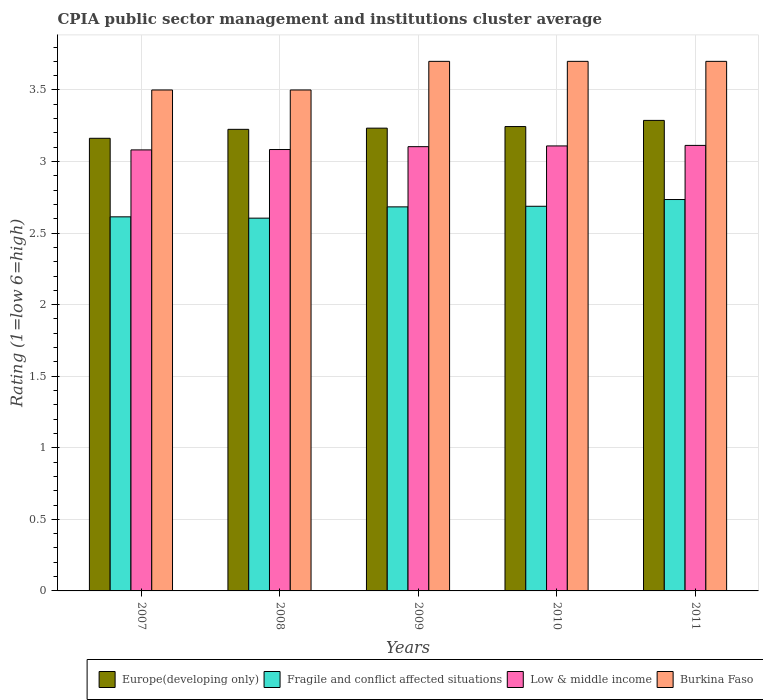How many different coloured bars are there?
Give a very brief answer. 4. Are the number of bars per tick equal to the number of legend labels?
Keep it short and to the point. Yes. How many bars are there on the 5th tick from the left?
Make the answer very short. 4. What is the CPIA rating in Fragile and conflict affected situations in 2009?
Offer a terse response. 2.68. Across all years, what is the maximum CPIA rating in Europe(developing only)?
Offer a very short reply. 3.29. Across all years, what is the minimum CPIA rating in Fragile and conflict affected situations?
Your answer should be compact. 2.6. In which year was the CPIA rating in Low & middle income maximum?
Ensure brevity in your answer.  2011. What is the total CPIA rating in Fragile and conflict affected situations in the graph?
Provide a short and direct response. 13.32. What is the difference between the CPIA rating in Low & middle income in 2007 and that in 2009?
Your answer should be compact. -0.02. What is the difference between the CPIA rating in Fragile and conflict affected situations in 2007 and the CPIA rating in Burkina Faso in 2010?
Your answer should be compact. -1.09. What is the average CPIA rating in Europe(developing only) per year?
Ensure brevity in your answer.  3.23. In the year 2009, what is the difference between the CPIA rating in Fragile and conflict affected situations and CPIA rating in Low & middle income?
Offer a terse response. -0.42. What is the ratio of the CPIA rating in Fragile and conflict affected situations in 2007 to that in 2009?
Give a very brief answer. 0.97. Is the CPIA rating in Burkina Faso in 2010 less than that in 2011?
Your response must be concise. No. What is the difference between the highest and the second highest CPIA rating in Low & middle income?
Offer a terse response. 0. What is the difference between the highest and the lowest CPIA rating in Low & middle income?
Provide a succinct answer. 0.03. Is the sum of the CPIA rating in Burkina Faso in 2010 and 2011 greater than the maximum CPIA rating in Fragile and conflict affected situations across all years?
Provide a short and direct response. Yes. What does the 2nd bar from the left in 2010 represents?
Make the answer very short. Fragile and conflict affected situations. What does the 2nd bar from the right in 2007 represents?
Give a very brief answer. Low & middle income. Is it the case that in every year, the sum of the CPIA rating in Fragile and conflict affected situations and CPIA rating in Europe(developing only) is greater than the CPIA rating in Burkina Faso?
Provide a short and direct response. Yes. How many bars are there?
Give a very brief answer. 20. How many years are there in the graph?
Give a very brief answer. 5. What is the difference between two consecutive major ticks on the Y-axis?
Your answer should be compact. 0.5. Does the graph contain grids?
Keep it short and to the point. Yes. How are the legend labels stacked?
Your response must be concise. Horizontal. What is the title of the graph?
Ensure brevity in your answer.  CPIA public sector management and institutions cluster average. What is the Rating (1=low 6=high) of Europe(developing only) in 2007?
Give a very brief answer. 3.16. What is the Rating (1=low 6=high) of Fragile and conflict affected situations in 2007?
Your answer should be compact. 2.61. What is the Rating (1=low 6=high) in Low & middle income in 2007?
Keep it short and to the point. 3.08. What is the Rating (1=low 6=high) of Burkina Faso in 2007?
Make the answer very short. 3.5. What is the Rating (1=low 6=high) of Europe(developing only) in 2008?
Your response must be concise. 3.23. What is the Rating (1=low 6=high) in Fragile and conflict affected situations in 2008?
Give a very brief answer. 2.6. What is the Rating (1=low 6=high) of Low & middle income in 2008?
Keep it short and to the point. 3.08. What is the Rating (1=low 6=high) in Burkina Faso in 2008?
Provide a short and direct response. 3.5. What is the Rating (1=low 6=high) in Europe(developing only) in 2009?
Make the answer very short. 3.23. What is the Rating (1=low 6=high) of Fragile and conflict affected situations in 2009?
Your answer should be compact. 2.68. What is the Rating (1=low 6=high) in Low & middle income in 2009?
Your answer should be compact. 3.1. What is the Rating (1=low 6=high) of Europe(developing only) in 2010?
Offer a terse response. 3.24. What is the Rating (1=low 6=high) in Fragile and conflict affected situations in 2010?
Your answer should be very brief. 2.69. What is the Rating (1=low 6=high) of Low & middle income in 2010?
Offer a very short reply. 3.11. What is the Rating (1=low 6=high) of Europe(developing only) in 2011?
Your answer should be compact. 3.29. What is the Rating (1=low 6=high) of Fragile and conflict affected situations in 2011?
Give a very brief answer. 2.73. What is the Rating (1=low 6=high) of Low & middle income in 2011?
Your response must be concise. 3.11. Across all years, what is the maximum Rating (1=low 6=high) in Europe(developing only)?
Keep it short and to the point. 3.29. Across all years, what is the maximum Rating (1=low 6=high) of Fragile and conflict affected situations?
Make the answer very short. 2.73. Across all years, what is the maximum Rating (1=low 6=high) in Low & middle income?
Your response must be concise. 3.11. Across all years, what is the minimum Rating (1=low 6=high) of Europe(developing only)?
Keep it short and to the point. 3.16. Across all years, what is the minimum Rating (1=low 6=high) of Fragile and conflict affected situations?
Provide a succinct answer. 2.6. Across all years, what is the minimum Rating (1=low 6=high) of Low & middle income?
Make the answer very short. 3.08. What is the total Rating (1=low 6=high) in Europe(developing only) in the graph?
Your answer should be very brief. 16.15. What is the total Rating (1=low 6=high) of Fragile and conflict affected situations in the graph?
Provide a succinct answer. 13.32. What is the total Rating (1=low 6=high) in Low & middle income in the graph?
Keep it short and to the point. 15.49. What is the difference between the Rating (1=low 6=high) in Europe(developing only) in 2007 and that in 2008?
Provide a succinct answer. -0.06. What is the difference between the Rating (1=low 6=high) in Fragile and conflict affected situations in 2007 and that in 2008?
Give a very brief answer. 0.01. What is the difference between the Rating (1=low 6=high) of Low & middle income in 2007 and that in 2008?
Ensure brevity in your answer.  -0. What is the difference between the Rating (1=low 6=high) of Europe(developing only) in 2007 and that in 2009?
Your response must be concise. -0.07. What is the difference between the Rating (1=low 6=high) of Fragile and conflict affected situations in 2007 and that in 2009?
Keep it short and to the point. -0.07. What is the difference between the Rating (1=low 6=high) of Low & middle income in 2007 and that in 2009?
Your response must be concise. -0.02. What is the difference between the Rating (1=low 6=high) in Burkina Faso in 2007 and that in 2009?
Give a very brief answer. -0.2. What is the difference between the Rating (1=low 6=high) in Europe(developing only) in 2007 and that in 2010?
Provide a succinct answer. -0.08. What is the difference between the Rating (1=low 6=high) of Fragile and conflict affected situations in 2007 and that in 2010?
Your answer should be very brief. -0.07. What is the difference between the Rating (1=low 6=high) of Low & middle income in 2007 and that in 2010?
Your answer should be very brief. -0.03. What is the difference between the Rating (1=low 6=high) of Burkina Faso in 2007 and that in 2010?
Ensure brevity in your answer.  -0.2. What is the difference between the Rating (1=low 6=high) in Europe(developing only) in 2007 and that in 2011?
Keep it short and to the point. -0.12. What is the difference between the Rating (1=low 6=high) in Fragile and conflict affected situations in 2007 and that in 2011?
Make the answer very short. -0.12. What is the difference between the Rating (1=low 6=high) of Low & middle income in 2007 and that in 2011?
Your response must be concise. -0.03. What is the difference between the Rating (1=low 6=high) of Europe(developing only) in 2008 and that in 2009?
Your response must be concise. -0.01. What is the difference between the Rating (1=low 6=high) of Fragile and conflict affected situations in 2008 and that in 2009?
Ensure brevity in your answer.  -0.08. What is the difference between the Rating (1=low 6=high) of Low & middle income in 2008 and that in 2009?
Offer a terse response. -0.02. What is the difference between the Rating (1=low 6=high) of Burkina Faso in 2008 and that in 2009?
Your answer should be very brief. -0.2. What is the difference between the Rating (1=low 6=high) in Europe(developing only) in 2008 and that in 2010?
Give a very brief answer. -0.02. What is the difference between the Rating (1=low 6=high) of Fragile and conflict affected situations in 2008 and that in 2010?
Your answer should be very brief. -0.08. What is the difference between the Rating (1=low 6=high) of Low & middle income in 2008 and that in 2010?
Your answer should be compact. -0.03. What is the difference between the Rating (1=low 6=high) of Burkina Faso in 2008 and that in 2010?
Make the answer very short. -0.2. What is the difference between the Rating (1=low 6=high) in Europe(developing only) in 2008 and that in 2011?
Make the answer very short. -0.06. What is the difference between the Rating (1=low 6=high) in Fragile and conflict affected situations in 2008 and that in 2011?
Provide a succinct answer. -0.13. What is the difference between the Rating (1=low 6=high) in Low & middle income in 2008 and that in 2011?
Provide a short and direct response. -0.03. What is the difference between the Rating (1=low 6=high) of Europe(developing only) in 2009 and that in 2010?
Offer a very short reply. -0.01. What is the difference between the Rating (1=low 6=high) of Fragile and conflict affected situations in 2009 and that in 2010?
Make the answer very short. -0. What is the difference between the Rating (1=low 6=high) of Low & middle income in 2009 and that in 2010?
Offer a very short reply. -0.01. What is the difference between the Rating (1=low 6=high) of Burkina Faso in 2009 and that in 2010?
Your answer should be compact. 0. What is the difference between the Rating (1=low 6=high) of Europe(developing only) in 2009 and that in 2011?
Keep it short and to the point. -0.05. What is the difference between the Rating (1=low 6=high) in Fragile and conflict affected situations in 2009 and that in 2011?
Offer a terse response. -0.05. What is the difference between the Rating (1=low 6=high) in Low & middle income in 2009 and that in 2011?
Offer a terse response. -0.01. What is the difference between the Rating (1=low 6=high) in Europe(developing only) in 2010 and that in 2011?
Your answer should be compact. -0.04. What is the difference between the Rating (1=low 6=high) of Fragile and conflict affected situations in 2010 and that in 2011?
Provide a short and direct response. -0.05. What is the difference between the Rating (1=low 6=high) of Low & middle income in 2010 and that in 2011?
Ensure brevity in your answer.  -0. What is the difference between the Rating (1=low 6=high) in Europe(developing only) in 2007 and the Rating (1=low 6=high) in Fragile and conflict affected situations in 2008?
Provide a succinct answer. 0.56. What is the difference between the Rating (1=low 6=high) in Europe(developing only) in 2007 and the Rating (1=low 6=high) in Low & middle income in 2008?
Provide a succinct answer. 0.08. What is the difference between the Rating (1=low 6=high) in Europe(developing only) in 2007 and the Rating (1=low 6=high) in Burkina Faso in 2008?
Make the answer very short. -0.34. What is the difference between the Rating (1=low 6=high) in Fragile and conflict affected situations in 2007 and the Rating (1=low 6=high) in Low & middle income in 2008?
Offer a terse response. -0.47. What is the difference between the Rating (1=low 6=high) of Fragile and conflict affected situations in 2007 and the Rating (1=low 6=high) of Burkina Faso in 2008?
Provide a succinct answer. -0.89. What is the difference between the Rating (1=low 6=high) in Low & middle income in 2007 and the Rating (1=low 6=high) in Burkina Faso in 2008?
Offer a terse response. -0.42. What is the difference between the Rating (1=low 6=high) in Europe(developing only) in 2007 and the Rating (1=low 6=high) in Fragile and conflict affected situations in 2009?
Provide a short and direct response. 0.48. What is the difference between the Rating (1=low 6=high) of Europe(developing only) in 2007 and the Rating (1=low 6=high) of Low & middle income in 2009?
Provide a succinct answer. 0.06. What is the difference between the Rating (1=low 6=high) of Europe(developing only) in 2007 and the Rating (1=low 6=high) of Burkina Faso in 2009?
Offer a terse response. -0.54. What is the difference between the Rating (1=low 6=high) in Fragile and conflict affected situations in 2007 and the Rating (1=low 6=high) in Low & middle income in 2009?
Keep it short and to the point. -0.49. What is the difference between the Rating (1=low 6=high) in Fragile and conflict affected situations in 2007 and the Rating (1=low 6=high) in Burkina Faso in 2009?
Your response must be concise. -1.09. What is the difference between the Rating (1=low 6=high) in Low & middle income in 2007 and the Rating (1=low 6=high) in Burkina Faso in 2009?
Your response must be concise. -0.62. What is the difference between the Rating (1=low 6=high) of Europe(developing only) in 2007 and the Rating (1=low 6=high) of Fragile and conflict affected situations in 2010?
Your response must be concise. 0.47. What is the difference between the Rating (1=low 6=high) of Europe(developing only) in 2007 and the Rating (1=low 6=high) of Low & middle income in 2010?
Provide a succinct answer. 0.05. What is the difference between the Rating (1=low 6=high) in Europe(developing only) in 2007 and the Rating (1=low 6=high) in Burkina Faso in 2010?
Provide a succinct answer. -0.54. What is the difference between the Rating (1=low 6=high) of Fragile and conflict affected situations in 2007 and the Rating (1=low 6=high) of Low & middle income in 2010?
Offer a terse response. -0.5. What is the difference between the Rating (1=low 6=high) of Fragile and conflict affected situations in 2007 and the Rating (1=low 6=high) of Burkina Faso in 2010?
Provide a short and direct response. -1.09. What is the difference between the Rating (1=low 6=high) in Low & middle income in 2007 and the Rating (1=low 6=high) in Burkina Faso in 2010?
Your answer should be very brief. -0.62. What is the difference between the Rating (1=low 6=high) of Europe(developing only) in 2007 and the Rating (1=low 6=high) of Fragile and conflict affected situations in 2011?
Give a very brief answer. 0.43. What is the difference between the Rating (1=low 6=high) in Europe(developing only) in 2007 and the Rating (1=low 6=high) in Low & middle income in 2011?
Make the answer very short. 0.05. What is the difference between the Rating (1=low 6=high) in Europe(developing only) in 2007 and the Rating (1=low 6=high) in Burkina Faso in 2011?
Your response must be concise. -0.54. What is the difference between the Rating (1=low 6=high) in Fragile and conflict affected situations in 2007 and the Rating (1=low 6=high) in Low & middle income in 2011?
Your answer should be very brief. -0.5. What is the difference between the Rating (1=low 6=high) in Fragile and conflict affected situations in 2007 and the Rating (1=low 6=high) in Burkina Faso in 2011?
Give a very brief answer. -1.09. What is the difference between the Rating (1=low 6=high) of Low & middle income in 2007 and the Rating (1=low 6=high) of Burkina Faso in 2011?
Your answer should be compact. -0.62. What is the difference between the Rating (1=low 6=high) in Europe(developing only) in 2008 and the Rating (1=low 6=high) in Fragile and conflict affected situations in 2009?
Offer a terse response. 0.54. What is the difference between the Rating (1=low 6=high) in Europe(developing only) in 2008 and the Rating (1=low 6=high) in Low & middle income in 2009?
Your answer should be compact. 0.12. What is the difference between the Rating (1=low 6=high) of Europe(developing only) in 2008 and the Rating (1=low 6=high) of Burkina Faso in 2009?
Make the answer very short. -0.47. What is the difference between the Rating (1=low 6=high) in Fragile and conflict affected situations in 2008 and the Rating (1=low 6=high) in Low & middle income in 2009?
Provide a succinct answer. -0.5. What is the difference between the Rating (1=low 6=high) in Fragile and conflict affected situations in 2008 and the Rating (1=low 6=high) in Burkina Faso in 2009?
Ensure brevity in your answer.  -1.1. What is the difference between the Rating (1=low 6=high) in Low & middle income in 2008 and the Rating (1=low 6=high) in Burkina Faso in 2009?
Give a very brief answer. -0.62. What is the difference between the Rating (1=low 6=high) of Europe(developing only) in 2008 and the Rating (1=low 6=high) of Fragile and conflict affected situations in 2010?
Make the answer very short. 0.54. What is the difference between the Rating (1=low 6=high) of Europe(developing only) in 2008 and the Rating (1=low 6=high) of Low & middle income in 2010?
Make the answer very short. 0.12. What is the difference between the Rating (1=low 6=high) in Europe(developing only) in 2008 and the Rating (1=low 6=high) in Burkina Faso in 2010?
Provide a short and direct response. -0.47. What is the difference between the Rating (1=low 6=high) of Fragile and conflict affected situations in 2008 and the Rating (1=low 6=high) of Low & middle income in 2010?
Give a very brief answer. -0.5. What is the difference between the Rating (1=low 6=high) in Fragile and conflict affected situations in 2008 and the Rating (1=low 6=high) in Burkina Faso in 2010?
Offer a very short reply. -1.1. What is the difference between the Rating (1=low 6=high) of Low & middle income in 2008 and the Rating (1=low 6=high) of Burkina Faso in 2010?
Keep it short and to the point. -0.62. What is the difference between the Rating (1=low 6=high) of Europe(developing only) in 2008 and the Rating (1=low 6=high) of Fragile and conflict affected situations in 2011?
Your answer should be compact. 0.49. What is the difference between the Rating (1=low 6=high) of Europe(developing only) in 2008 and the Rating (1=low 6=high) of Low & middle income in 2011?
Make the answer very short. 0.11. What is the difference between the Rating (1=low 6=high) of Europe(developing only) in 2008 and the Rating (1=low 6=high) of Burkina Faso in 2011?
Offer a terse response. -0.47. What is the difference between the Rating (1=low 6=high) of Fragile and conflict affected situations in 2008 and the Rating (1=low 6=high) of Low & middle income in 2011?
Give a very brief answer. -0.51. What is the difference between the Rating (1=low 6=high) of Fragile and conflict affected situations in 2008 and the Rating (1=low 6=high) of Burkina Faso in 2011?
Provide a short and direct response. -1.1. What is the difference between the Rating (1=low 6=high) in Low & middle income in 2008 and the Rating (1=low 6=high) in Burkina Faso in 2011?
Provide a short and direct response. -0.62. What is the difference between the Rating (1=low 6=high) in Europe(developing only) in 2009 and the Rating (1=low 6=high) in Fragile and conflict affected situations in 2010?
Make the answer very short. 0.55. What is the difference between the Rating (1=low 6=high) in Europe(developing only) in 2009 and the Rating (1=low 6=high) in Low & middle income in 2010?
Keep it short and to the point. 0.12. What is the difference between the Rating (1=low 6=high) in Europe(developing only) in 2009 and the Rating (1=low 6=high) in Burkina Faso in 2010?
Offer a terse response. -0.47. What is the difference between the Rating (1=low 6=high) of Fragile and conflict affected situations in 2009 and the Rating (1=low 6=high) of Low & middle income in 2010?
Your answer should be very brief. -0.43. What is the difference between the Rating (1=low 6=high) in Fragile and conflict affected situations in 2009 and the Rating (1=low 6=high) in Burkina Faso in 2010?
Make the answer very short. -1.02. What is the difference between the Rating (1=low 6=high) of Low & middle income in 2009 and the Rating (1=low 6=high) of Burkina Faso in 2010?
Provide a short and direct response. -0.6. What is the difference between the Rating (1=low 6=high) of Europe(developing only) in 2009 and the Rating (1=low 6=high) of Fragile and conflict affected situations in 2011?
Provide a succinct answer. 0.5. What is the difference between the Rating (1=low 6=high) of Europe(developing only) in 2009 and the Rating (1=low 6=high) of Low & middle income in 2011?
Your answer should be very brief. 0.12. What is the difference between the Rating (1=low 6=high) of Europe(developing only) in 2009 and the Rating (1=low 6=high) of Burkina Faso in 2011?
Offer a terse response. -0.47. What is the difference between the Rating (1=low 6=high) in Fragile and conflict affected situations in 2009 and the Rating (1=low 6=high) in Low & middle income in 2011?
Keep it short and to the point. -0.43. What is the difference between the Rating (1=low 6=high) of Fragile and conflict affected situations in 2009 and the Rating (1=low 6=high) of Burkina Faso in 2011?
Make the answer very short. -1.02. What is the difference between the Rating (1=low 6=high) of Low & middle income in 2009 and the Rating (1=low 6=high) of Burkina Faso in 2011?
Keep it short and to the point. -0.6. What is the difference between the Rating (1=low 6=high) of Europe(developing only) in 2010 and the Rating (1=low 6=high) of Fragile and conflict affected situations in 2011?
Ensure brevity in your answer.  0.51. What is the difference between the Rating (1=low 6=high) of Europe(developing only) in 2010 and the Rating (1=low 6=high) of Low & middle income in 2011?
Provide a succinct answer. 0.13. What is the difference between the Rating (1=low 6=high) in Europe(developing only) in 2010 and the Rating (1=low 6=high) in Burkina Faso in 2011?
Provide a short and direct response. -0.46. What is the difference between the Rating (1=low 6=high) in Fragile and conflict affected situations in 2010 and the Rating (1=low 6=high) in Low & middle income in 2011?
Give a very brief answer. -0.43. What is the difference between the Rating (1=low 6=high) of Fragile and conflict affected situations in 2010 and the Rating (1=low 6=high) of Burkina Faso in 2011?
Offer a very short reply. -1.01. What is the difference between the Rating (1=low 6=high) in Low & middle income in 2010 and the Rating (1=low 6=high) in Burkina Faso in 2011?
Give a very brief answer. -0.59. What is the average Rating (1=low 6=high) in Europe(developing only) per year?
Give a very brief answer. 3.23. What is the average Rating (1=low 6=high) of Fragile and conflict affected situations per year?
Provide a short and direct response. 2.66. What is the average Rating (1=low 6=high) in Low & middle income per year?
Offer a terse response. 3.1. What is the average Rating (1=low 6=high) in Burkina Faso per year?
Your answer should be compact. 3.62. In the year 2007, what is the difference between the Rating (1=low 6=high) in Europe(developing only) and Rating (1=low 6=high) in Fragile and conflict affected situations?
Make the answer very short. 0.55. In the year 2007, what is the difference between the Rating (1=low 6=high) in Europe(developing only) and Rating (1=low 6=high) in Low & middle income?
Ensure brevity in your answer.  0.08. In the year 2007, what is the difference between the Rating (1=low 6=high) of Europe(developing only) and Rating (1=low 6=high) of Burkina Faso?
Keep it short and to the point. -0.34. In the year 2007, what is the difference between the Rating (1=low 6=high) in Fragile and conflict affected situations and Rating (1=low 6=high) in Low & middle income?
Make the answer very short. -0.47. In the year 2007, what is the difference between the Rating (1=low 6=high) of Fragile and conflict affected situations and Rating (1=low 6=high) of Burkina Faso?
Offer a terse response. -0.89. In the year 2007, what is the difference between the Rating (1=low 6=high) of Low & middle income and Rating (1=low 6=high) of Burkina Faso?
Ensure brevity in your answer.  -0.42. In the year 2008, what is the difference between the Rating (1=low 6=high) in Europe(developing only) and Rating (1=low 6=high) in Fragile and conflict affected situations?
Your answer should be compact. 0.62. In the year 2008, what is the difference between the Rating (1=low 6=high) in Europe(developing only) and Rating (1=low 6=high) in Low & middle income?
Provide a short and direct response. 0.14. In the year 2008, what is the difference between the Rating (1=low 6=high) in Europe(developing only) and Rating (1=low 6=high) in Burkina Faso?
Provide a short and direct response. -0.28. In the year 2008, what is the difference between the Rating (1=low 6=high) in Fragile and conflict affected situations and Rating (1=low 6=high) in Low & middle income?
Make the answer very short. -0.48. In the year 2008, what is the difference between the Rating (1=low 6=high) in Fragile and conflict affected situations and Rating (1=low 6=high) in Burkina Faso?
Your response must be concise. -0.9. In the year 2008, what is the difference between the Rating (1=low 6=high) in Low & middle income and Rating (1=low 6=high) in Burkina Faso?
Provide a short and direct response. -0.42. In the year 2009, what is the difference between the Rating (1=low 6=high) of Europe(developing only) and Rating (1=low 6=high) of Fragile and conflict affected situations?
Keep it short and to the point. 0.55. In the year 2009, what is the difference between the Rating (1=low 6=high) of Europe(developing only) and Rating (1=low 6=high) of Low & middle income?
Ensure brevity in your answer.  0.13. In the year 2009, what is the difference between the Rating (1=low 6=high) of Europe(developing only) and Rating (1=low 6=high) of Burkina Faso?
Offer a very short reply. -0.47. In the year 2009, what is the difference between the Rating (1=low 6=high) of Fragile and conflict affected situations and Rating (1=low 6=high) of Low & middle income?
Keep it short and to the point. -0.42. In the year 2009, what is the difference between the Rating (1=low 6=high) of Fragile and conflict affected situations and Rating (1=low 6=high) of Burkina Faso?
Your answer should be very brief. -1.02. In the year 2009, what is the difference between the Rating (1=low 6=high) in Low & middle income and Rating (1=low 6=high) in Burkina Faso?
Offer a terse response. -0.6. In the year 2010, what is the difference between the Rating (1=low 6=high) in Europe(developing only) and Rating (1=low 6=high) in Fragile and conflict affected situations?
Offer a terse response. 0.56. In the year 2010, what is the difference between the Rating (1=low 6=high) in Europe(developing only) and Rating (1=low 6=high) in Low & middle income?
Ensure brevity in your answer.  0.14. In the year 2010, what is the difference between the Rating (1=low 6=high) of Europe(developing only) and Rating (1=low 6=high) of Burkina Faso?
Keep it short and to the point. -0.46. In the year 2010, what is the difference between the Rating (1=low 6=high) of Fragile and conflict affected situations and Rating (1=low 6=high) of Low & middle income?
Make the answer very short. -0.42. In the year 2010, what is the difference between the Rating (1=low 6=high) in Fragile and conflict affected situations and Rating (1=low 6=high) in Burkina Faso?
Your answer should be compact. -1.01. In the year 2010, what is the difference between the Rating (1=low 6=high) in Low & middle income and Rating (1=low 6=high) in Burkina Faso?
Make the answer very short. -0.59. In the year 2011, what is the difference between the Rating (1=low 6=high) of Europe(developing only) and Rating (1=low 6=high) of Fragile and conflict affected situations?
Give a very brief answer. 0.55. In the year 2011, what is the difference between the Rating (1=low 6=high) in Europe(developing only) and Rating (1=low 6=high) in Low & middle income?
Your answer should be compact. 0.17. In the year 2011, what is the difference between the Rating (1=low 6=high) in Europe(developing only) and Rating (1=low 6=high) in Burkina Faso?
Offer a terse response. -0.41. In the year 2011, what is the difference between the Rating (1=low 6=high) of Fragile and conflict affected situations and Rating (1=low 6=high) of Low & middle income?
Your answer should be very brief. -0.38. In the year 2011, what is the difference between the Rating (1=low 6=high) in Fragile and conflict affected situations and Rating (1=low 6=high) in Burkina Faso?
Keep it short and to the point. -0.97. In the year 2011, what is the difference between the Rating (1=low 6=high) in Low & middle income and Rating (1=low 6=high) in Burkina Faso?
Offer a terse response. -0.59. What is the ratio of the Rating (1=low 6=high) of Europe(developing only) in 2007 to that in 2008?
Your answer should be compact. 0.98. What is the ratio of the Rating (1=low 6=high) of Fragile and conflict affected situations in 2007 to that in 2008?
Offer a terse response. 1. What is the ratio of the Rating (1=low 6=high) of Low & middle income in 2007 to that in 2008?
Your answer should be compact. 1. What is the ratio of the Rating (1=low 6=high) of Burkina Faso in 2007 to that in 2008?
Provide a short and direct response. 1. What is the ratio of the Rating (1=low 6=high) in Europe(developing only) in 2007 to that in 2009?
Keep it short and to the point. 0.98. What is the ratio of the Rating (1=low 6=high) of Fragile and conflict affected situations in 2007 to that in 2009?
Give a very brief answer. 0.97. What is the ratio of the Rating (1=low 6=high) of Burkina Faso in 2007 to that in 2009?
Offer a terse response. 0.95. What is the ratio of the Rating (1=low 6=high) of Europe(developing only) in 2007 to that in 2010?
Your answer should be compact. 0.97. What is the ratio of the Rating (1=low 6=high) in Fragile and conflict affected situations in 2007 to that in 2010?
Your answer should be very brief. 0.97. What is the ratio of the Rating (1=low 6=high) of Burkina Faso in 2007 to that in 2010?
Keep it short and to the point. 0.95. What is the ratio of the Rating (1=low 6=high) of Europe(developing only) in 2007 to that in 2011?
Make the answer very short. 0.96. What is the ratio of the Rating (1=low 6=high) in Fragile and conflict affected situations in 2007 to that in 2011?
Your answer should be compact. 0.96. What is the ratio of the Rating (1=low 6=high) of Burkina Faso in 2007 to that in 2011?
Make the answer very short. 0.95. What is the ratio of the Rating (1=low 6=high) in Fragile and conflict affected situations in 2008 to that in 2009?
Give a very brief answer. 0.97. What is the ratio of the Rating (1=low 6=high) of Burkina Faso in 2008 to that in 2009?
Your answer should be compact. 0.95. What is the ratio of the Rating (1=low 6=high) in Europe(developing only) in 2008 to that in 2010?
Make the answer very short. 0.99. What is the ratio of the Rating (1=low 6=high) of Fragile and conflict affected situations in 2008 to that in 2010?
Offer a terse response. 0.97. What is the ratio of the Rating (1=low 6=high) in Low & middle income in 2008 to that in 2010?
Keep it short and to the point. 0.99. What is the ratio of the Rating (1=low 6=high) in Burkina Faso in 2008 to that in 2010?
Your answer should be very brief. 0.95. What is the ratio of the Rating (1=low 6=high) of Europe(developing only) in 2008 to that in 2011?
Offer a very short reply. 0.98. What is the ratio of the Rating (1=low 6=high) of Burkina Faso in 2008 to that in 2011?
Your answer should be very brief. 0.95. What is the ratio of the Rating (1=low 6=high) of Europe(developing only) in 2009 to that in 2011?
Ensure brevity in your answer.  0.98. What is the ratio of the Rating (1=low 6=high) in Fragile and conflict affected situations in 2009 to that in 2011?
Ensure brevity in your answer.  0.98. What is the ratio of the Rating (1=low 6=high) in Low & middle income in 2009 to that in 2011?
Your answer should be compact. 1. What is the ratio of the Rating (1=low 6=high) in Burkina Faso in 2009 to that in 2011?
Provide a succinct answer. 1. What is the ratio of the Rating (1=low 6=high) of Europe(developing only) in 2010 to that in 2011?
Provide a short and direct response. 0.99. What is the ratio of the Rating (1=low 6=high) in Fragile and conflict affected situations in 2010 to that in 2011?
Your answer should be very brief. 0.98. What is the difference between the highest and the second highest Rating (1=low 6=high) in Europe(developing only)?
Offer a very short reply. 0.04. What is the difference between the highest and the second highest Rating (1=low 6=high) in Fragile and conflict affected situations?
Give a very brief answer. 0.05. What is the difference between the highest and the second highest Rating (1=low 6=high) of Low & middle income?
Your response must be concise. 0. What is the difference between the highest and the lowest Rating (1=low 6=high) of Fragile and conflict affected situations?
Your answer should be compact. 0.13. What is the difference between the highest and the lowest Rating (1=low 6=high) in Low & middle income?
Provide a succinct answer. 0.03. 